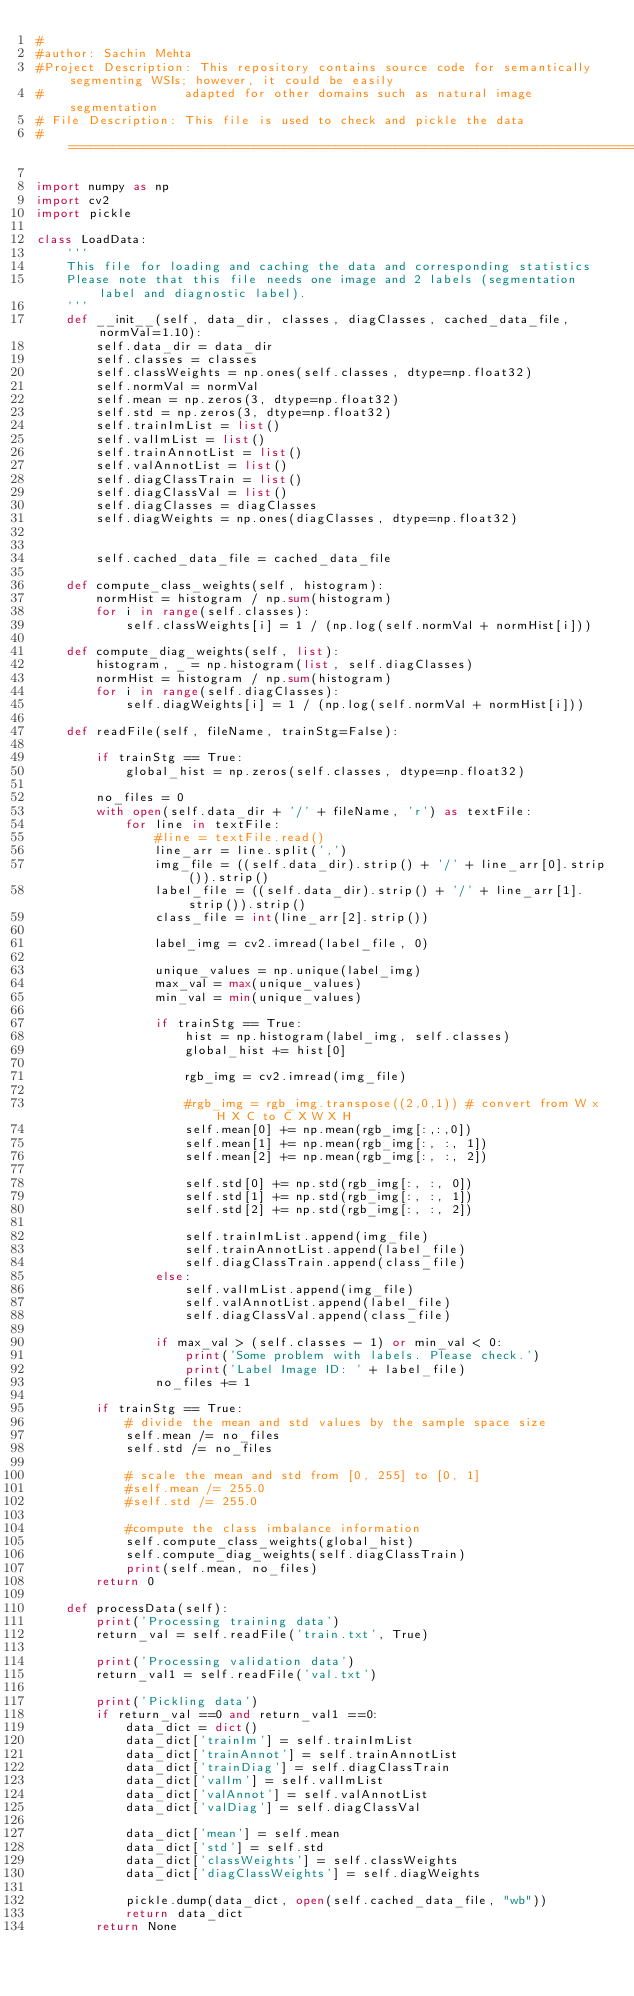<code> <loc_0><loc_0><loc_500><loc_500><_Python_>#
#author: Sachin Mehta
#Project Description: This repository contains source code for semantically segmenting WSIs; however, it could be easily
#                   adapted for other domains such as natural image segmentation
# File Description: This file is used to check and pickle the data
#==============================================================================

import numpy as np
import cv2
import pickle

class LoadData:
    '''
    This file for loading and caching the data and corresponding statistics
    Please note that this file needs one image and 2 labels (segmentation label and diagnostic label).
    '''
    def __init__(self, data_dir, classes, diagClasses, cached_data_file, normVal=1.10):
        self.data_dir = data_dir
        self.classes = classes
        self.classWeights = np.ones(self.classes, dtype=np.float32)
        self.normVal = normVal
        self.mean = np.zeros(3, dtype=np.float32)
        self.std = np.zeros(3, dtype=np.float32)
        self.trainImList = list()
        self.valImList = list()
        self.trainAnnotList = list()
        self.valAnnotList = list()
        self.diagClassTrain = list()
        self.diagClassVal = list()
        self.diagClasses = diagClasses
        self.diagWeights = np.ones(diagClasses, dtype=np.float32)


        self.cached_data_file = cached_data_file

    def compute_class_weights(self, histogram):
        normHist = histogram / np.sum(histogram)
        for i in range(self.classes):
            self.classWeights[i] = 1 / (np.log(self.normVal + normHist[i]))
            
    def compute_diag_weights(self, list):
        histogram, _ = np.histogram(list, self.diagClasses)
        normHist = histogram / np.sum(histogram)
        for i in range(self.diagClasses):
            self.diagWeights[i] = 1 / (np.log(self.normVal + normHist[i]))

    def readFile(self, fileName, trainStg=False):

        if trainStg == True:
            global_hist = np.zeros(self.classes, dtype=np.float32)

        no_files = 0
        with open(self.data_dir + '/' + fileName, 'r') as textFile:
            for line in textFile:
                #line = textFile.read()
                line_arr = line.split(',')
                img_file = ((self.data_dir).strip() + '/' + line_arr[0].strip()).strip()
                label_file = ((self.data_dir).strip() + '/' + line_arr[1].strip()).strip()
                class_file = int(line_arr[2].strip())

                label_img = cv2.imread(label_file, 0)

                unique_values = np.unique(label_img)
                max_val = max(unique_values)
                min_val = min(unique_values)

                if trainStg == True:
                    hist = np.histogram(label_img, self.classes)
                    global_hist += hist[0]

                    rgb_img = cv2.imread(img_file)

                    #rgb_img = rgb_img.transpose((2,0,1)) # convert from W x H X C to C X W X H
                    self.mean[0] += np.mean(rgb_img[:,:,0])
                    self.mean[1] += np.mean(rgb_img[:, :, 1])
                    self.mean[2] += np.mean(rgb_img[:, :, 2])

                    self.std[0] += np.std(rgb_img[:, :, 0])
                    self.std[1] += np.std(rgb_img[:, :, 1])
                    self.std[2] += np.std(rgb_img[:, :, 2])

                    self.trainImList.append(img_file)
                    self.trainAnnotList.append(label_file)
                    self.diagClassTrain.append(class_file)
                else:
                    self.valImList.append(img_file)
                    self.valAnnotList.append(label_file)
                    self.diagClassVal.append(class_file)

                if max_val > (self.classes - 1) or min_val < 0:
                    print('Some problem with labels. Please check.')
                    print('Label Image ID: ' + label_file)
                no_files += 1

        if trainStg == True:
            # divide the mean and std values by the sample space size
            self.mean /= no_files
            self.std /= no_files

            # scale the mean and std from [0, 255] to [0, 1]
            #self.mean /= 255.0
            #self.std /= 255.0

            #compute the class imbalance information
            self.compute_class_weights(global_hist)
            self.compute_diag_weights(self.diagClassTrain)
            print(self.mean, no_files)
        return 0

    def processData(self):
        print('Processing training data')
        return_val = self.readFile('train.txt', True)

        print('Processing validation data')
        return_val1 = self.readFile('val.txt')

        print('Pickling data')
        if return_val ==0 and return_val1 ==0:
            data_dict = dict()
            data_dict['trainIm'] = self.trainImList
            data_dict['trainAnnot'] = self.trainAnnotList
            data_dict['trainDiag'] = self.diagClassTrain
            data_dict['valIm'] = self.valImList
            data_dict['valAnnot'] = self.valAnnotList
            data_dict['valDiag'] = self.diagClassVal

            data_dict['mean'] = self.mean
            data_dict['std'] = self.std
            data_dict['classWeights'] = self.classWeights
            data_dict['diagClassWeights'] = self.diagWeights

            pickle.dump(data_dict, open(self.cached_data_file, "wb"))
            return data_dict
        return None



</code> 